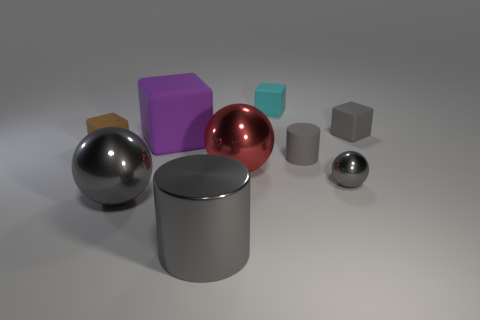There is a cylinder that is the same material as the large red thing; what size is it?
Your answer should be compact. Large. How many red things are either big shiny things or balls?
Provide a short and direct response. 1. There is a gray object that is behind the brown thing; what number of cyan matte things are left of it?
Provide a short and direct response. 1. Are there more brown rubber blocks on the right side of the brown block than red balls that are behind the cyan rubber thing?
Your answer should be compact. No. What is the material of the small brown cube?
Offer a terse response. Rubber. Is there a green metallic ball of the same size as the metallic cylinder?
Provide a succinct answer. No. There is a purple object that is the same size as the red object; what is it made of?
Give a very brief answer. Rubber. What number of tiny metallic cylinders are there?
Your answer should be compact. 0. What size is the gray thing that is behind the brown rubber cube?
Provide a succinct answer. Small. Are there an equal number of gray matte things in front of the tiny gray rubber cylinder and tiny green shiny blocks?
Ensure brevity in your answer.  Yes. 